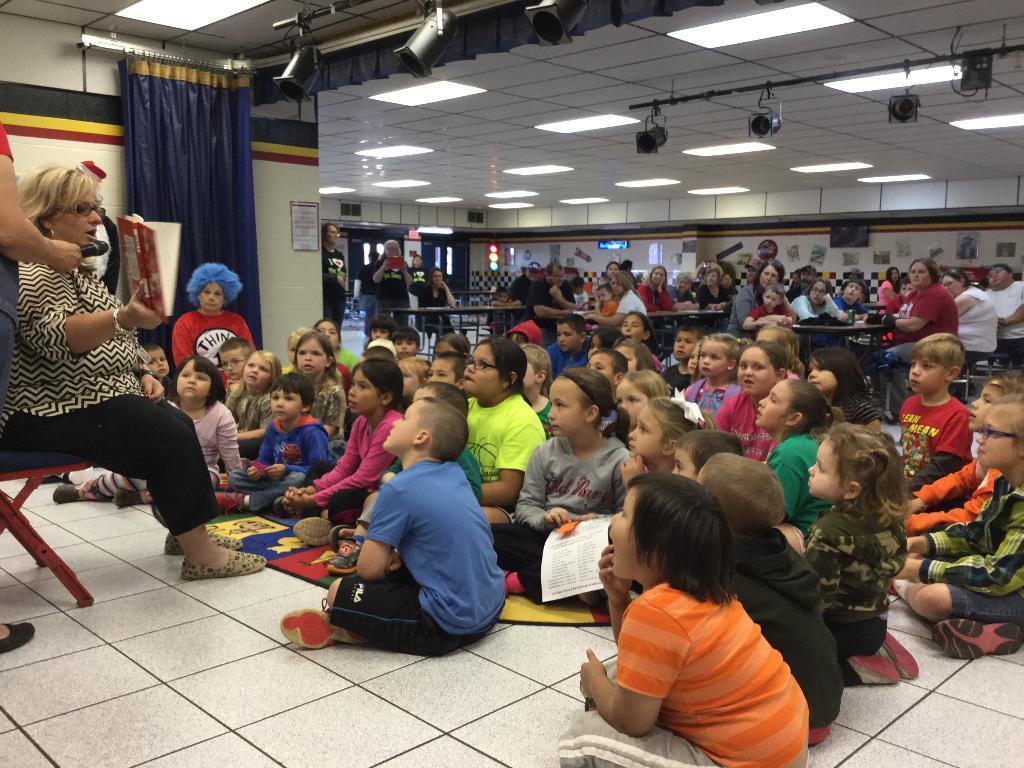Can you describe this image briefly? On the left side there is a lady sitting on the chair and speaking. She is wearing a specs. Another person is holding a mic. On the floor there are many children sitting. In the back there are many people sitting on chairs. On the ceiling there are lights. On the side there is a curtain. In the background there is a wall with lights. 